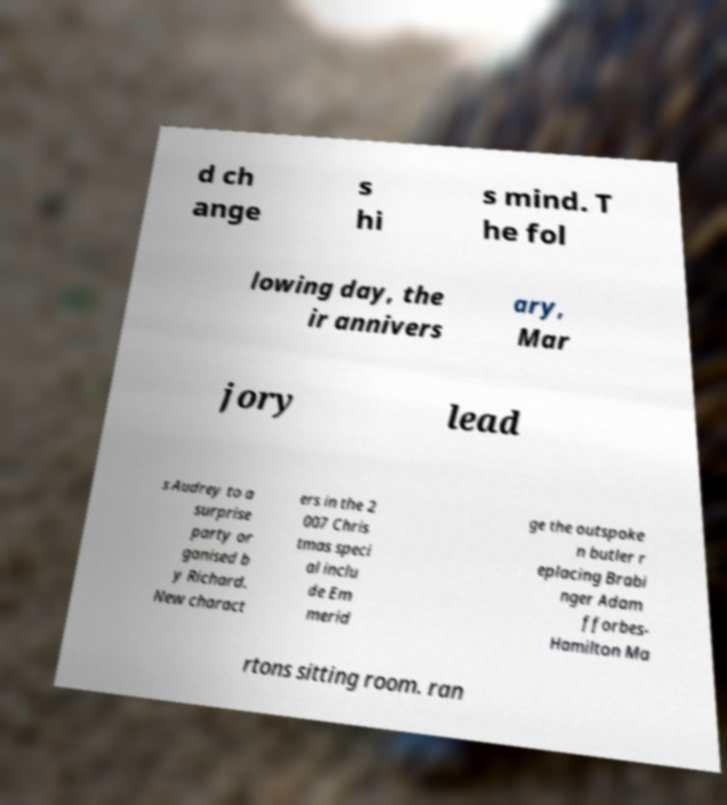Can you accurately transcribe the text from the provided image for me? d ch ange s hi s mind. T he fol lowing day, the ir annivers ary, Mar jory lead s Audrey to a surprise party or ganised b y Richard. New charact ers in the 2 007 Chris tmas speci al inclu de Em merid ge the outspoke n butler r eplacing Brabi nger Adam fforbes- Hamilton Ma rtons sitting room. ran 